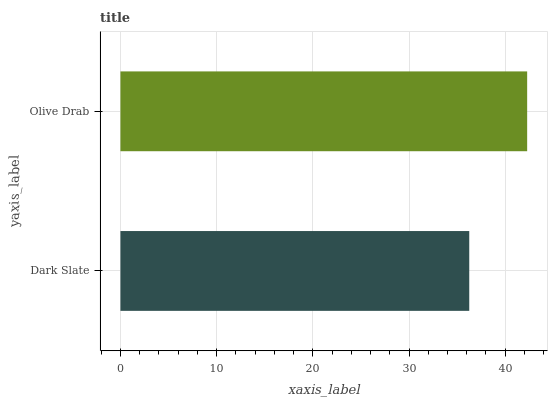Is Dark Slate the minimum?
Answer yes or no. Yes. Is Olive Drab the maximum?
Answer yes or no. Yes. Is Olive Drab the minimum?
Answer yes or no. No. Is Olive Drab greater than Dark Slate?
Answer yes or no. Yes. Is Dark Slate less than Olive Drab?
Answer yes or no. Yes. Is Dark Slate greater than Olive Drab?
Answer yes or no. No. Is Olive Drab less than Dark Slate?
Answer yes or no. No. Is Olive Drab the high median?
Answer yes or no. Yes. Is Dark Slate the low median?
Answer yes or no. Yes. Is Dark Slate the high median?
Answer yes or no. No. Is Olive Drab the low median?
Answer yes or no. No. 